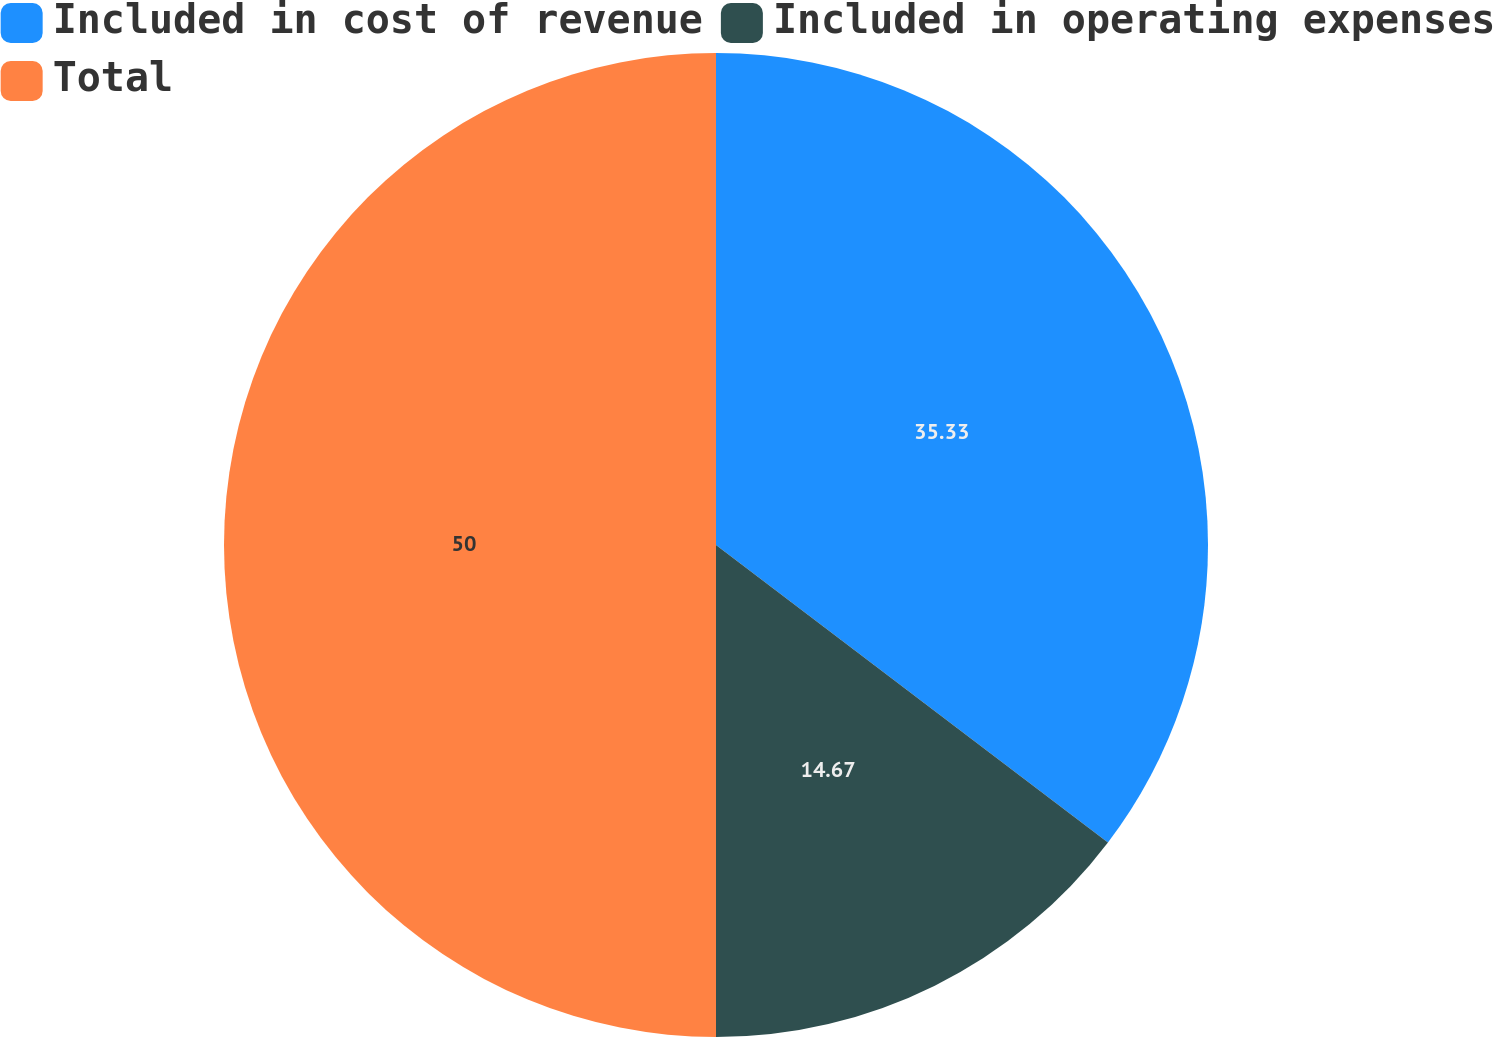Convert chart. <chart><loc_0><loc_0><loc_500><loc_500><pie_chart><fcel>Included in cost of revenue<fcel>Included in operating expenses<fcel>Total<nl><fcel>35.33%<fcel>14.67%<fcel>50.0%<nl></chart> 